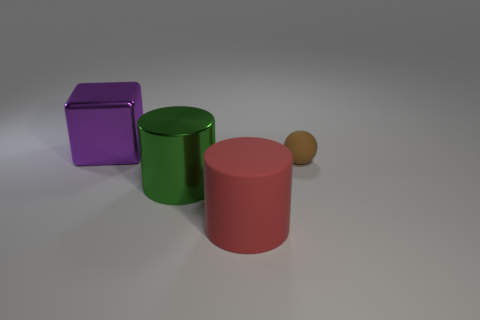Add 1 rubber things. How many objects exist? 5 Subtract all spheres. How many objects are left? 3 Add 2 small rubber balls. How many small rubber balls are left? 3 Add 4 tiny brown rubber spheres. How many tiny brown rubber spheres exist? 5 Subtract 0 cyan cubes. How many objects are left? 4 Subtract all large metal objects. Subtract all brown rubber balls. How many objects are left? 1 